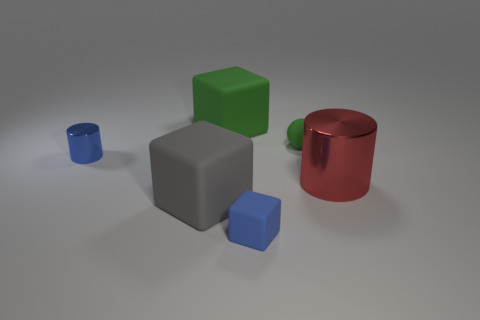What is the material of the object that is the same color as the tiny cube?
Make the answer very short. Metal. How many matte spheres are the same size as the blue block?
Offer a very short reply. 1. Is the number of big green rubber cubes in front of the big gray rubber cube the same as the number of big red metal cylinders?
Your answer should be very brief. No. What number of small blue objects are both on the right side of the blue metal object and behind the large gray matte thing?
Offer a terse response. 0. Is the shape of the big rubber thing that is in front of the big red object the same as  the blue shiny object?
Your answer should be very brief. No. There is a block that is the same size as the gray matte object; what is its material?
Offer a very short reply. Rubber. Is the number of tiny blue metallic objects in front of the small blue rubber object the same as the number of small green things that are in front of the red thing?
Make the answer very short. Yes. There is a cylinder that is to the left of the cylinder on the right side of the small metal cylinder; what number of small matte balls are to the left of it?
Keep it short and to the point. 0. There is a small rubber ball; is its color the same as the large cylinder that is on the right side of the green block?
Give a very brief answer. No. There is another gray cube that is the same material as the small block; what size is it?
Make the answer very short. Large. 